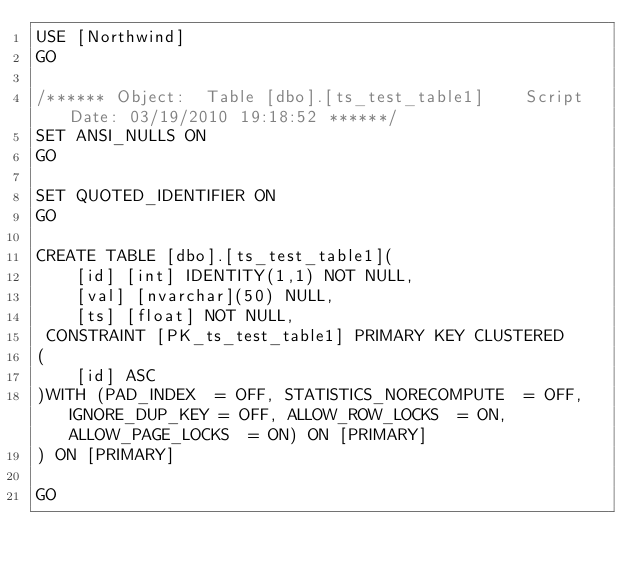Convert code to text. <code><loc_0><loc_0><loc_500><loc_500><_SQL_>USE [Northwind]
GO

/****** Object:  Table [dbo].[ts_test_table1]    Script Date: 03/19/2010 19:18:52 ******/
SET ANSI_NULLS ON
GO

SET QUOTED_IDENTIFIER ON
GO

CREATE TABLE [dbo].[ts_test_table1](
	[id] [int] IDENTITY(1,1) NOT NULL,
	[val] [nvarchar](50) NULL,
	[ts] [float] NOT NULL,
 CONSTRAINT [PK_ts_test_table1] PRIMARY KEY CLUSTERED 
(
	[id] ASC
)WITH (PAD_INDEX  = OFF, STATISTICS_NORECOMPUTE  = OFF, IGNORE_DUP_KEY = OFF, ALLOW_ROW_LOCKS  = ON, ALLOW_PAGE_LOCKS  = ON) ON [PRIMARY]
) ON [PRIMARY]

GO

</code> 